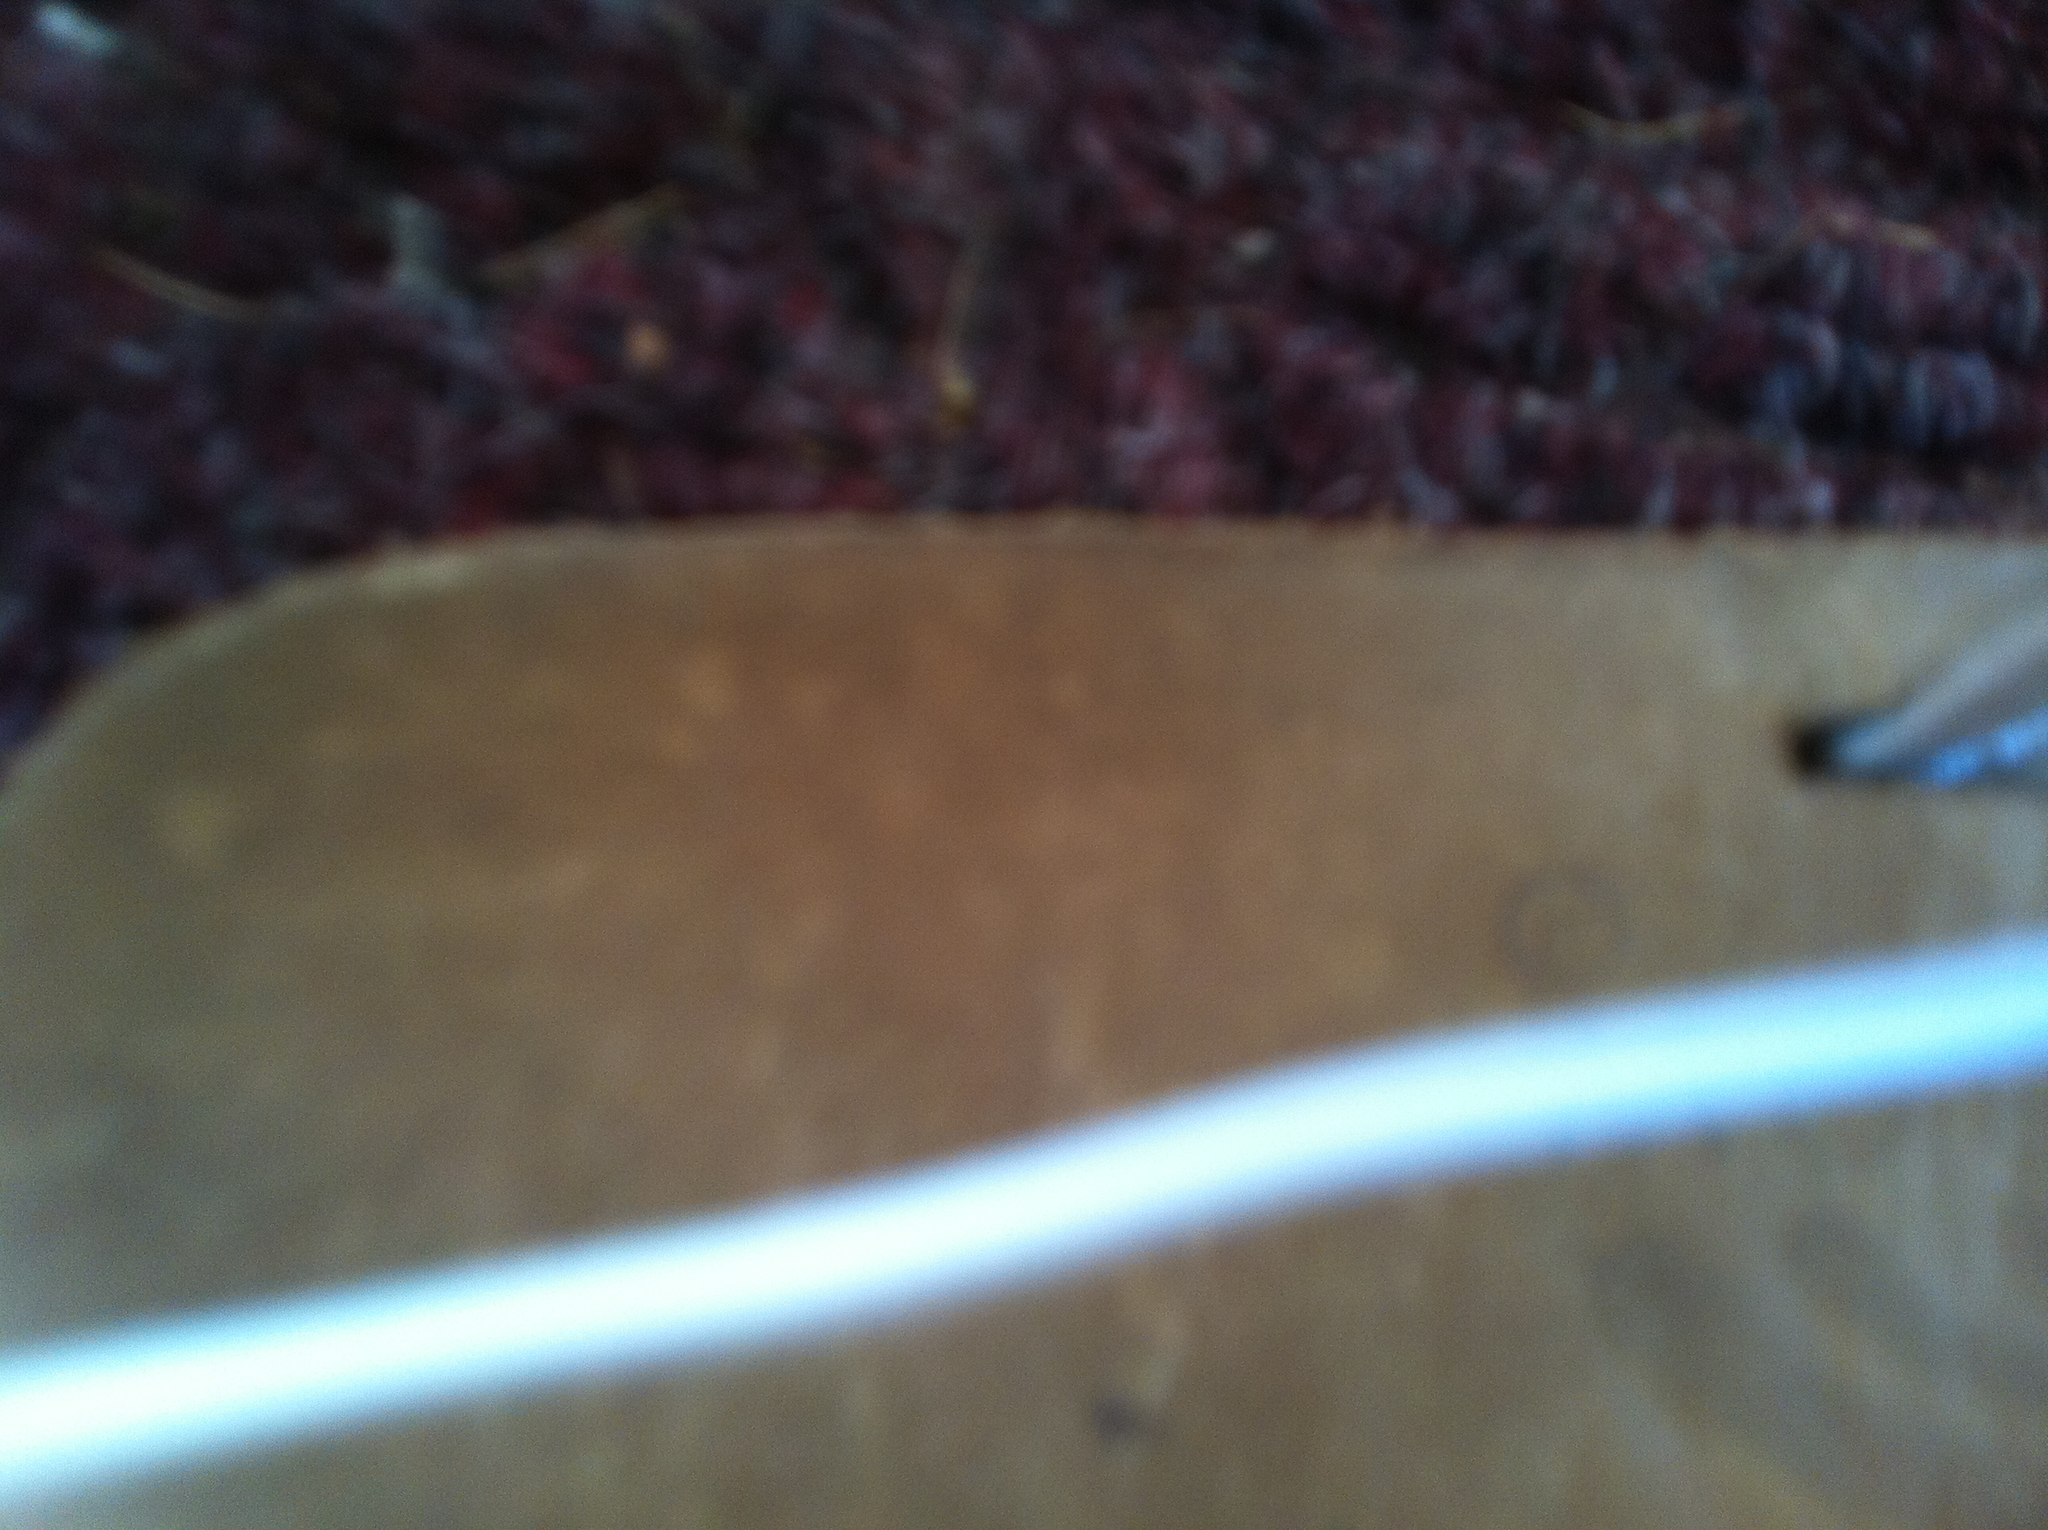What practical advice would you give to someone who wants to maintain a shoe like this? To maintain a shoe with a similar smooth and polished surface, it's important to regularly clean it with a soft cloth to remove dirt and stains. Use a suitable polish to keep the leather supple and shiny, and store the shoes in a dry, cool place to prevent any molding or deterioration. Additionally, using a shoe tree can help maintain its shape over time.  Can you write a detailed description of the surroundings where this shoe might typically be worn, including a narrative scenario? In a bustling city where the old meets the new, this shoe finds its place in the life of an executive. The mornings begin with a brisk walk through historic city streets, the shoe gently tapping the cobblestones, before transitioning to polished marble floors of a modern, glass-walled office building. As meetings unfold around a long mahogany table, the shoe remains silently poised, carrying the warmth of a well-worn history in its fabric. By evening, it finds itself amidst the quiet ambiance of a fine-dining restaurant, the dim lights casting a soft glow on its polished surface, as conversations hum and glasses clink. The shoe is a silent observer of the day’s journey, a bridge between the past and present, bearing stories in its very fabric. 